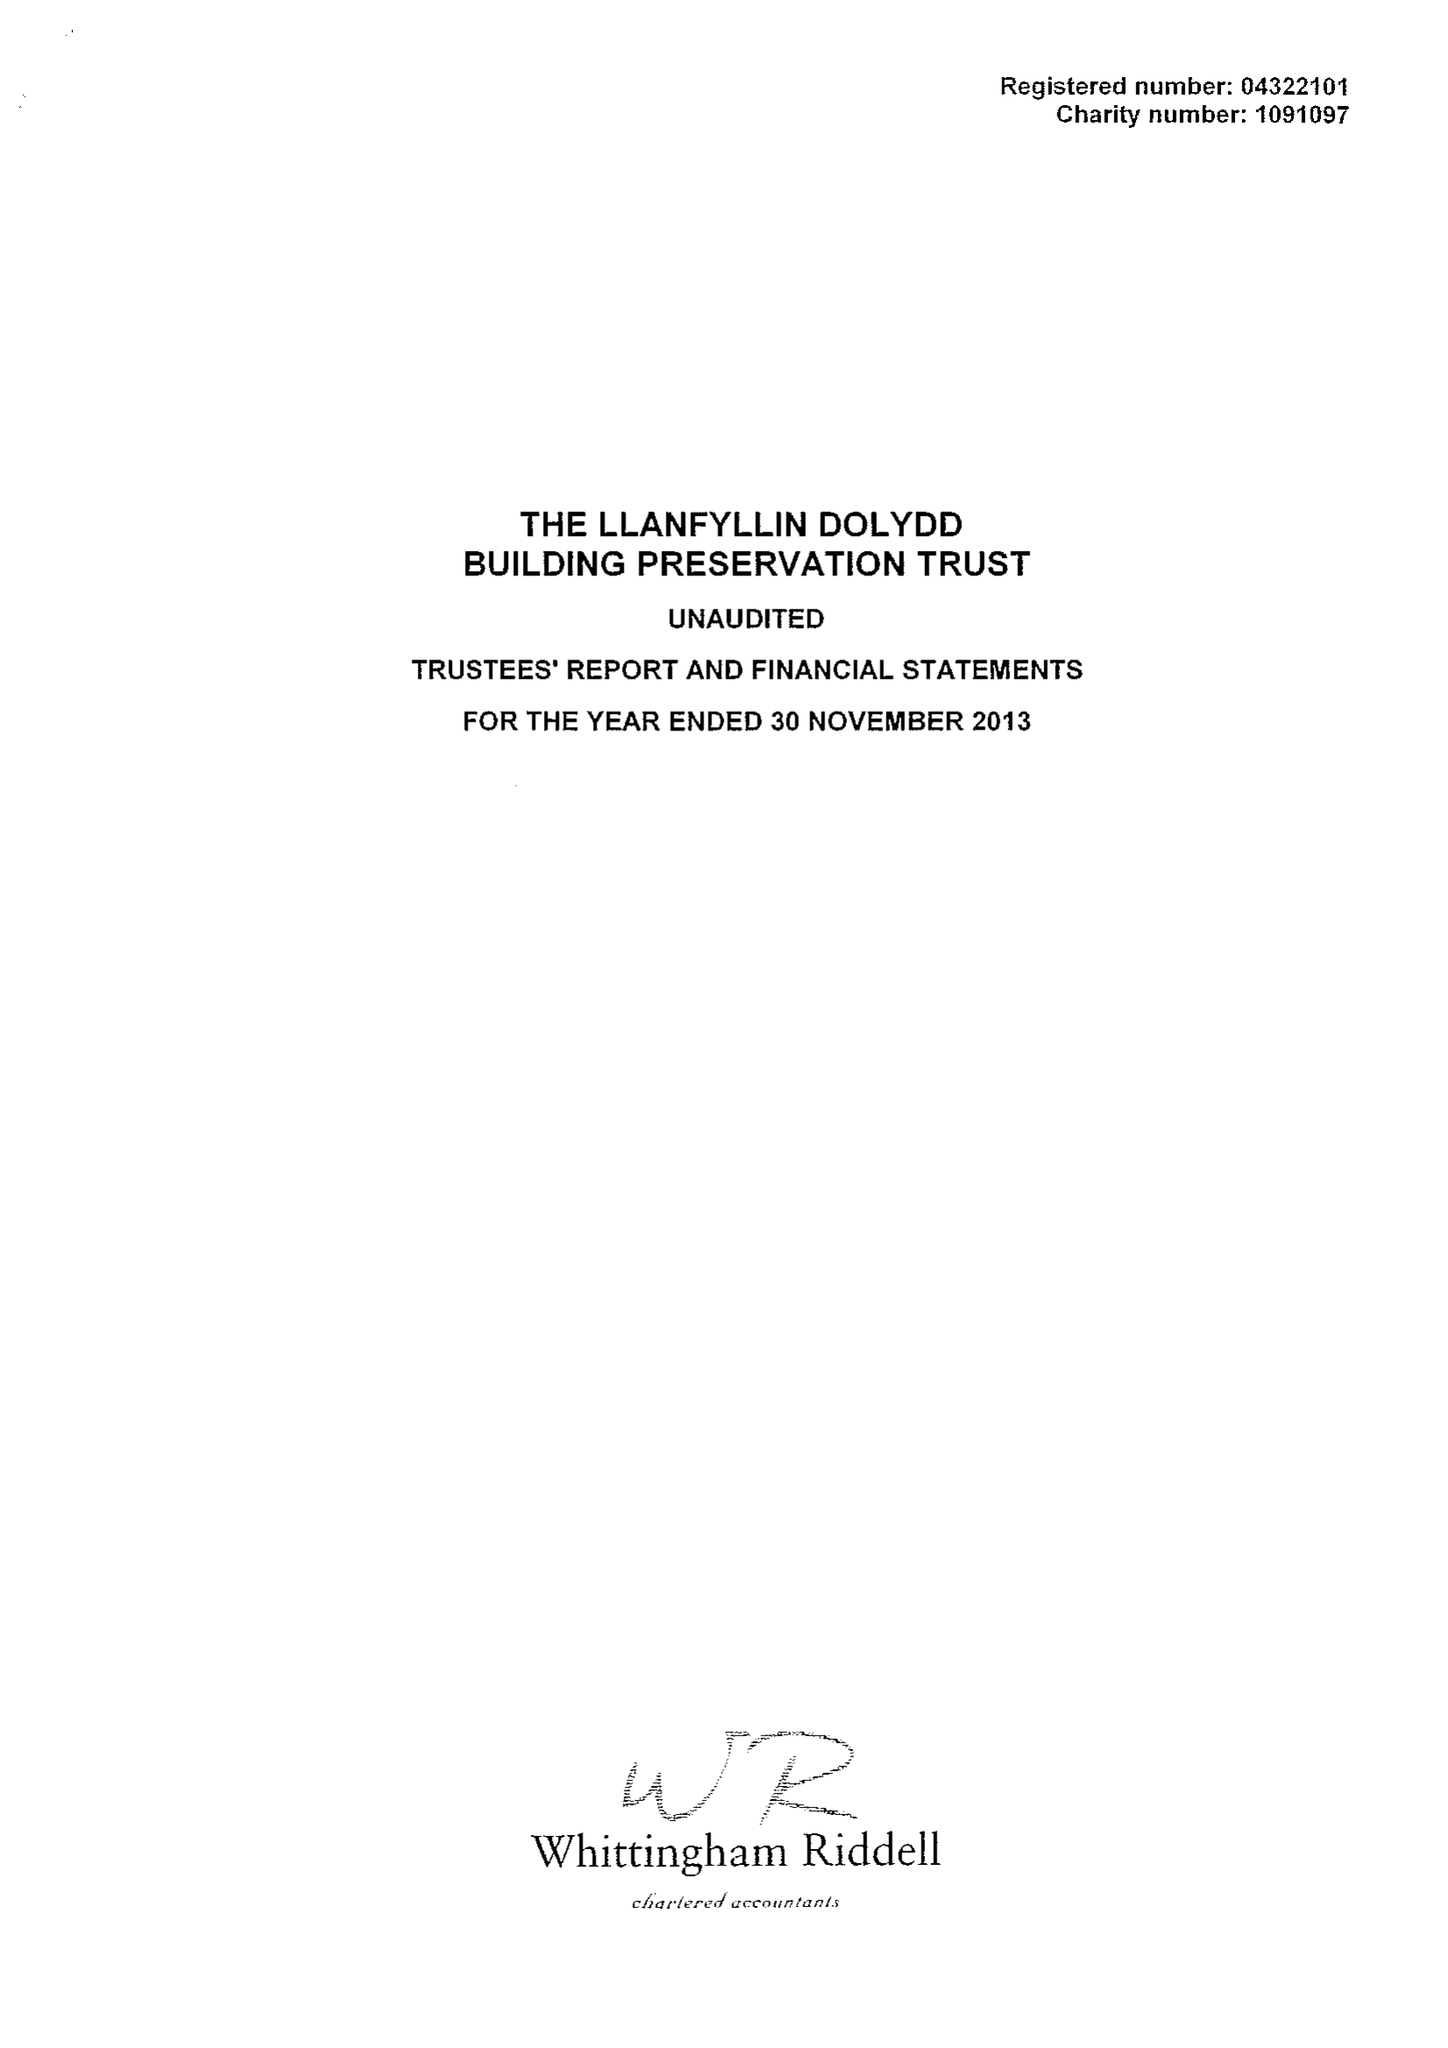What is the value for the charity_name?
Answer the question using a single word or phrase. Llanfyllin Dolydd Building Preservation Trust 